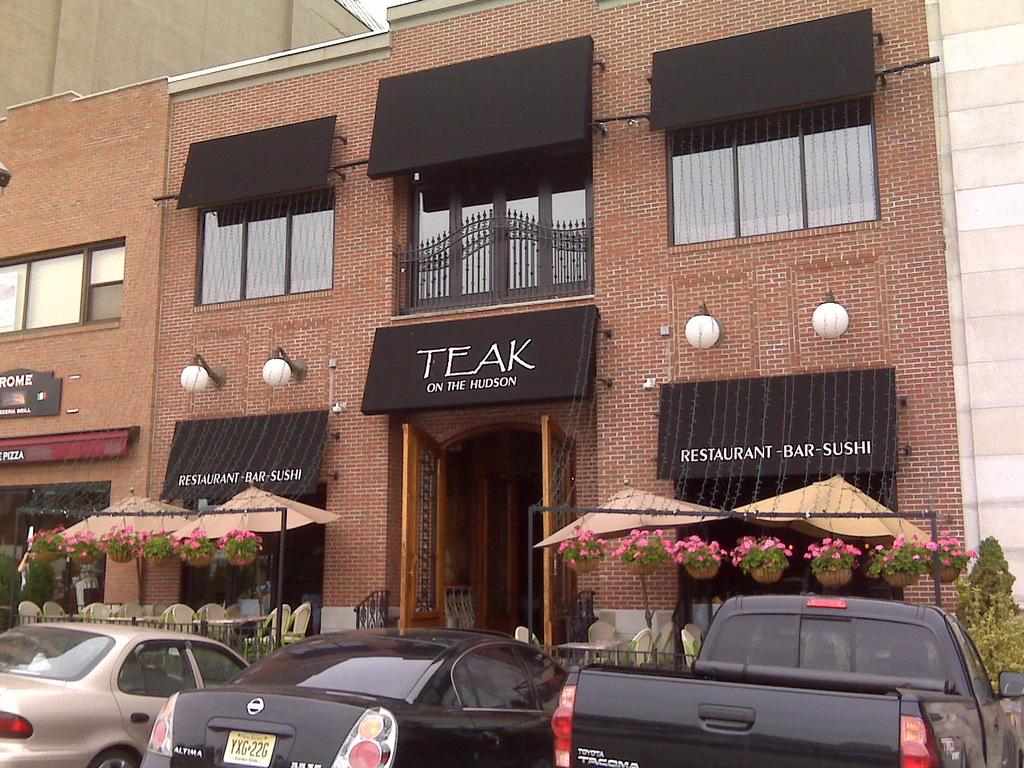What types of vehicles are in the image? There are cars and trucks in the image. What kind of building is in front of the cars and trucks? There is a brick building with many windows in the image. What type of establishment is present in the image? There is a hotel in the image. What decorative feature can be seen in front of the hotel? Flower plants are hanging in front of the hotel. What is the current recess time for the children playing in the image? There are no children playing in the image, nor is there any information about recess time. Can you see any sails in the image? There are no sails present in the image. 